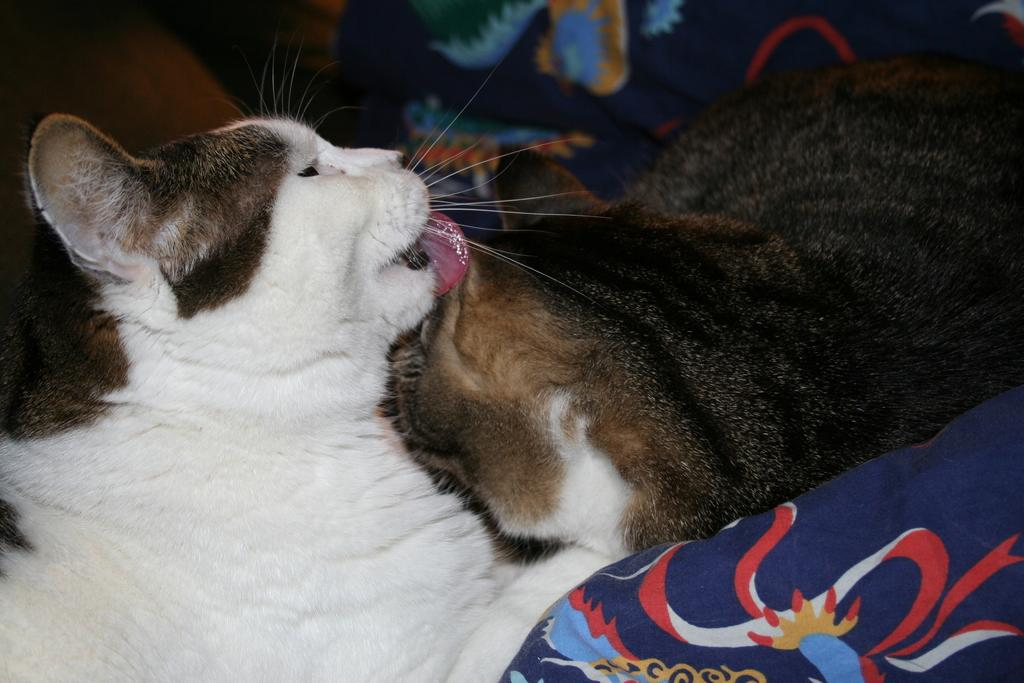How many cats are visible in the image? There are two cats visible in the image, one on the left side and another on the right side. Can you describe the position of the cats in the image? One cat is on the left side, and the other cat is on the right side. What type of bird is sitting on the shelf in the image? There is no bird or shelf present in the image; it features two cats, one on the left side and another on the right side. 